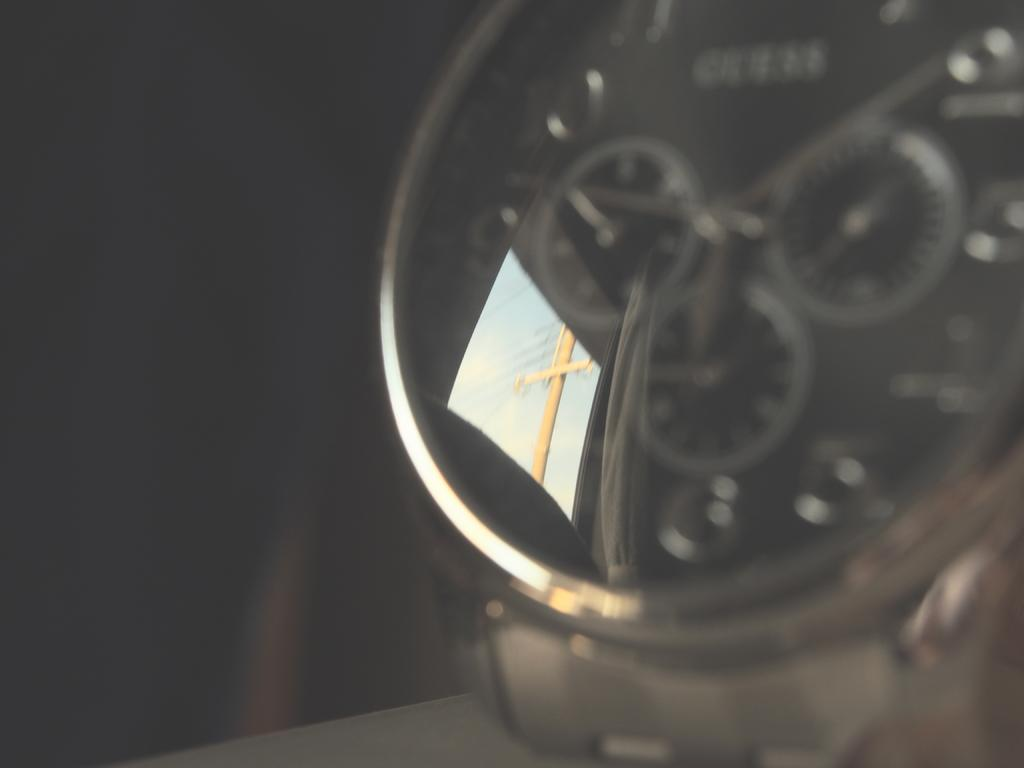What object is located on the right side of the image? There is a watch on the right side of the image. What can be seen on the watch glass? There are reflections of a pole, wires, and clouds in the sky on the watch glass. How would you describe the background of the image? The background of the image is dark. What type of book is the person reading in the image? There is no person or book present in the image; it features a watch with reflections on the watch glass. Can you tell me how many potatoes are visible in the image? There are no potatoes visible in the image; it features a watch with reflections on the watch glass. 